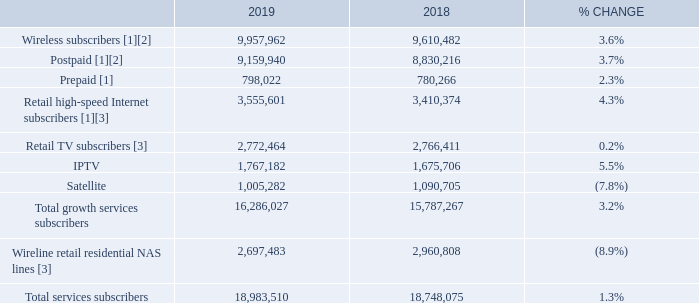TOTAL BCE CUSTOMER CONNECTIONS
(1) At the beginning of Q1 2019, we adjusted our wireless subscriber base to remove 167,929 subscribers (72,231 postpaid and 95,698 prepaid) as follows: (A) 65,798 subscribers (19,195 postpaid and 46,603 prepaid), due to the completion of the shutdown of the CDMA network on April 30, 2019, (B) 49,095 prepaid subscribers as a result of a change to our deactivation policy, mainly from 120 days for Bell/Virgin Mobile and 150 days for Lucky Mobile to 90 days, (C) 43,670 postpaid subscribers relating to IoT due to the further refinement of our subscriber definition as a result of technology evolution, and (D) 9,366 postpaid fixed wireless Internet subscribers which were transferred to our retail high-speed Internet subscriber base.
(2) At the beginning of Q4 2018, we adjusted our postpaid wireless subscriber base to remove 20,000 subscribers that we divested to Xplornet as a result of BCE’s acquisition of MTS in 2017.
(3) As of January 1, 2019, we are no longer reporting wholesale subscribers in our Internet, TV and residential NAS subscriber bases reflecting our focus on the retail market. Consequently, we restated previously reported 2018 subscribers for comparability.
BCE added 657,323 net new retail customer connections to its retail growth services in 2019, representing a 6.4% increase over 2018. This consisted of: • 401,955 postpaid wireless customers, and 113,454 prepaid wireless customers • 135,861 retail high-speed Internet customers • 6,053 retail TV customers comprised of 91,476 retail IPTV net customer additions and 85,423 retail satellite TV net customer losses
Retail residential NAS net losses were 263,325 in 2019, increasing by 1.7% over 2018.
Total BCE retail customer connections across all retail services grew by 1.3% in 2019, compared to last year, driven by an increase in our retail growth services customer base, offset in part by continued erosion in traditional retail residential NAS lines.
At the end of 2019, BCE retail customer connections totaled 18,983,510, and were comprised of the following: • 9,957,962 wireless subscribers, up 3.6% compared to 2018, comprised of 9,159,940 postpaid subscribers, an increase of 3.7% over last year, and 798,022 prepaid subscribers, up 2.3% year over year • 3,555,601 retail high-speed Internet subscribers, 4.3% higher than last year • 2,772,464 total retail TV subscribers, up 0.2% compared to 2018, comprised of 1,767,182 retail IPTV customers, up 5.5% year over year, and 1,005,282 retail satellite TV subscribers, down 7.8% year over year • 2,697,483 retail residential NAS lines, a decline of 8.9% compared to 2018
How many subscribers were removed upon adjusting the wireless subscriber base in 2019? 167,929. How many IPTV subscribers were there in 2018? 1,675,706. How many Satellite subscribers were there in 2019? 1,005,282. What is the percentage of prepaid subscribers out of the wireless subscribers in 2019?
Answer scale should be: percent. 798,022/9,957,962
Answer: 8.01. What is the change in the number of total services subscribers in 2019? 18,983,510-18,748,075
Answer: 235435. What is the percentage of Satellite subscribers out of the total number of subscribers in 2019?
Answer scale should be: percent. 1,005,282/18,983,510
Answer: 5.3. 